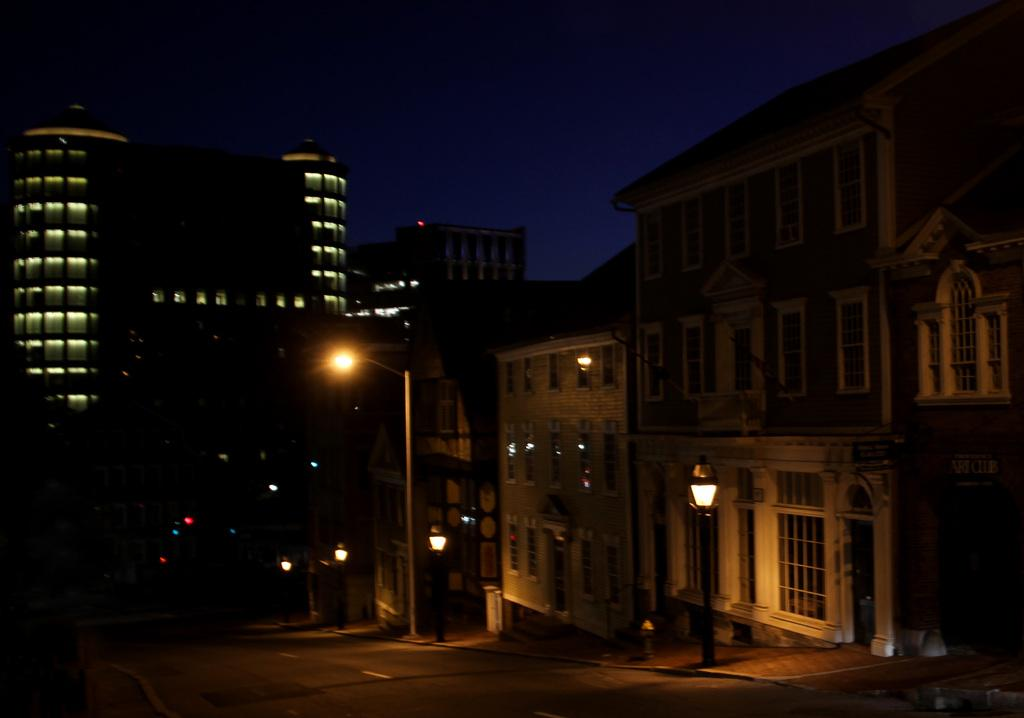What type of structures can be seen in the image? There are buildings in the image. What can be found along the road in the image? There are street lights in the image. What is the main feature of the image? The main feature of the image is a road. What is visible in the background of the image? The sky is visible in the background of the image. Can you describe the argument between the cat and the street light in the image? There is no cat or argument present in the image. What type of teeth can be seen on the buildings in the image? Buildings do not have teeth, so this cannot be answered. 